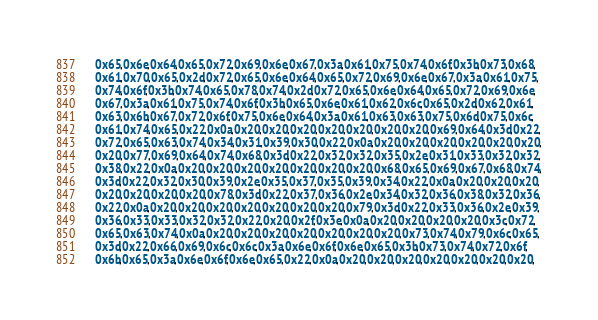Convert code to text. <code><loc_0><loc_0><loc_500><loc_500><_C_>    0x65,0x6e,0x64,0x65,0x72,0x69,0x6e,0x67,0x3a,0x61,0x75,0x74,0x6f,0x3b,0x73,0x68,
    0x61,0x70,0x65,0x2d,0x72,0x65,0x6e,0x64,0x65,0x72,0x69,0x6e,0x67,0x3a,0x61,0x75,
    0x74,0x6f,0x3b,0x74,0x65,0x78,0x74,0x2d,0x72,0x65,0x6e,0x64,0x65,0x72,0x69,0x6e,
    0x67,0x3a,0x61,0x75,0x74,0x6f,0x3b,0x65,0x6e,0x61,0x62,0x6c,0x65,0x2d,0x62,0x61,
    0x63,0x6b,0x67,0x72,0x6f,0x75,0x6e,0x64,0x3a,0x61,0x63,0x63,0x75,0x6d,0x75,0x6c,
    0x61,0x74,0x65,0x22,0x0a,0x20,0x20,0x20,0x20,0x20,0x20,0x20,0x69,0x64,0x3d,0x22,
    0x72,0x65,0x63,0x74,0x34,0x31,0x39,0x30,0x22,0x0a,0x20,0x20,0x20,0x20,0x20,0x20,
    0x20,0x77,0x69,0x64,0x74,0x68,0x3d,0x22,0x32,0x32,0x35,0x2e,0x31,0x33,0x32,0x32,
    0x38,0x22,0x0a,0x20,0x20,0x20,0x20,0x20,0x20,0x20,0x68,0x65,0x69,0x67,0x68,0x74,
    0x3d,0x22,0x32,0x30,0x39,0x2e,0x35,0x37,0x35,0x39,0x34,0x22,0x0a,0x20,0x20,0x20,
    0x20,0x20,0x20,0x20,0x78,0x3d,0x22,0x37,0x36,0x2e,0x34,0x32,0x36,0x38,0x32,0x36,
    0x22,0x0a,0x20,0x20,0x20,0x20,0x20,0x20,0x20,0x79,0x3d,0x22,0x33,0x36,0x2e,0x39,
    0x36,0x33,0x33,0x32,0x32,0x22,0x20,0x2f,0x3e,0x0a,0x20,0x20,0x20,0x20,0x3c,0x72,
    0x65,0x63,0x74,0x0a,0x20,0x20,0x20,0x20,0x20,0x20,0x20,0x73,0x74,0x79,0x6c,0x65,
    0x3d,0x22,0x66,0x69,0x6c,0x6c,0x3a,0x6e,0x6f,0x6e,0x65,0x3b,0x73,0x74,0x72,0x6f,
    0x6b,0x65,0x3a,0x6e,0x6f,0x6e,0x65,0x22,0x0a,0x20,0x20,0x20,0x20,0x20,0x20,0x20,</code> 